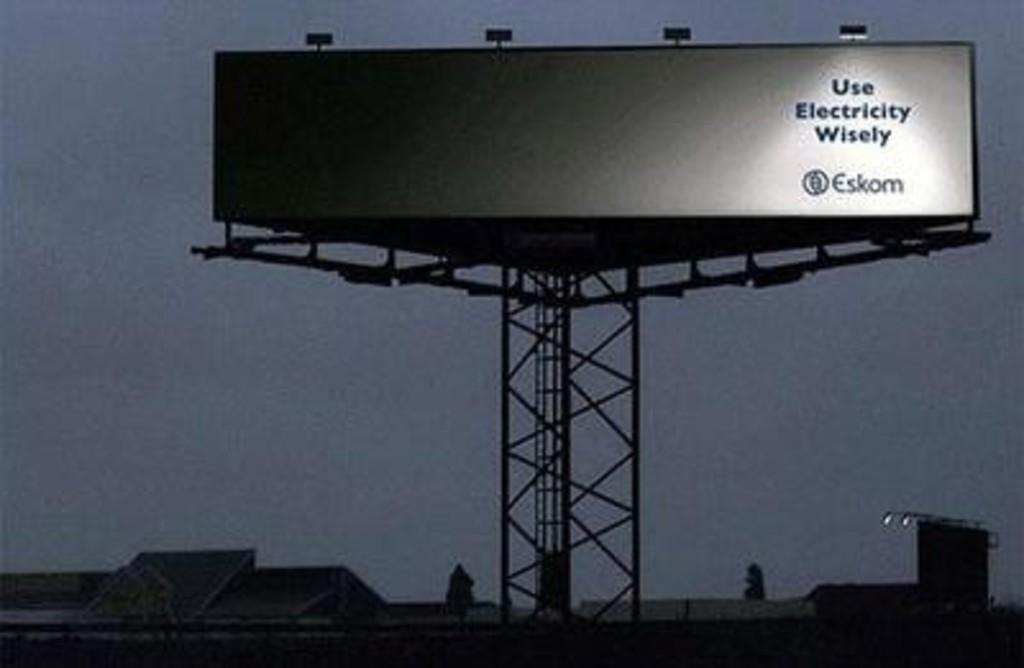What is the overall lighting condition in the image? The image is dark. What type of structures can be seen in the image? There are buildings and a huge tower in the image. What is attached to the tower? A huge banner is present on the tower. Are there any illuminated features on the tower? Yes, there are lights visible on the tower. What can be seen in the background of the image? The sky is visible in the background of the image. What type of seed is being planted in the pail in the image? There is no pail or seed present in the image; it features a huge tower with a banner and lights. How many apples are visible on the buildings in the image? There are no apples visible on the buildings in the image. 